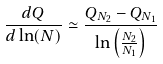Convert formula to latex. <formula><loc_0><loc_0><loc_500><loc_500>\frac { d Q } { d \ln ( N ) } \simeq \frac { Q _ { N _ { 2 } } - Q _ { N _ { 1 } } } { \ln \left ( \frac { N _ { 2 } } { N _ { 1 } } \right ) }</formula> 